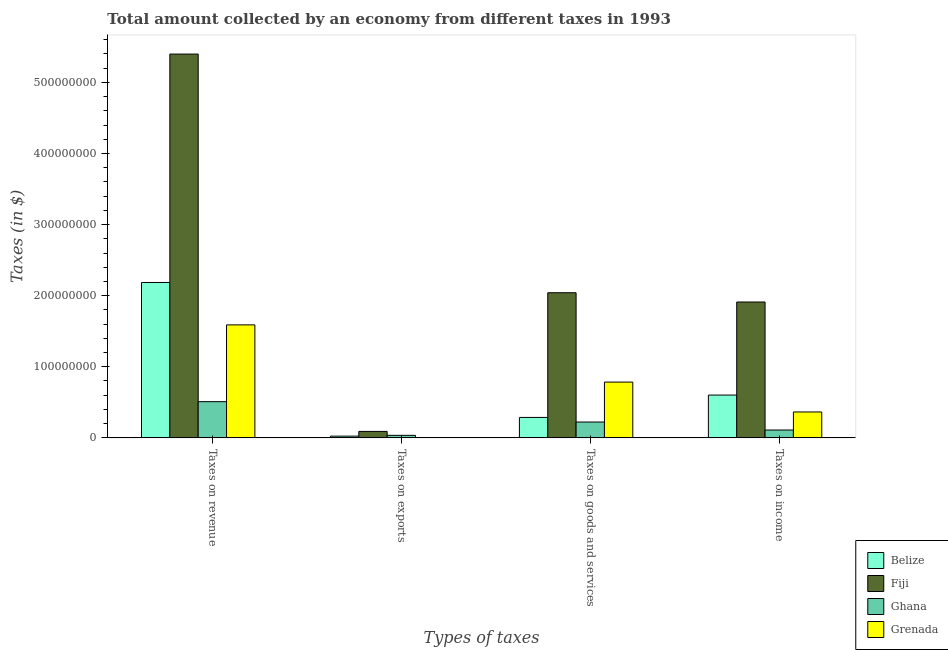Are the number of bars per tick equal to the number of legend labels?
Give a very brief answer. Yes. Are the number of bars on each tick of the X-axis equal?
Ensure brevity in your answer.  Yes. How many bars are there on the 2nd tick from the left?
Offer a very short reply. 4. What is the label of the 3rd group of bars from the left?
Your answer should be compact. Taxes on goods and services. What is the amount collected as tax on income in Grenada?
Offer a terse response. 3.64e+07. Across all countries, what is the maximum amount collected as tax on goods?
Ensure brevity in your answer.  2.04e+08. Across all countries, what is the minimum amount collected as tax on exports?
Provide a short and direct response. 10000. In which country was the amount collected as tax on revenue maximum?
Keep it short and to the point. Fiji. What is the total amount collected as tax on exports in the graph?
Keep it short and to the point. 1.51e+07. What is the difference between the amount collected as tax on income in Fiji and that in Grenada?
Make the answer very short. 1.55e+08. What is the difference between the amount collected as tax on goods in Ghana and the amount collected as tax on exports in Grenada?
Provide a short and direct response. 2.23e+07. What is the average amount collected as tax on exports per country?
Your response must be concise. 3.78e+06. What is the difference between the amount collected as tax on goods and amount collected as tax on revenue in Grenada?
Keep it short and to the point. -8.05e+07. In how many countries, is the amount collected as tax on revenue greater than 280000000 $?
Keep it short and to the point. 1. What is the ratio of the amount collected as tax on income in Belize to that in Fiji?
Ensure brevity in your answer.  0.31. What is the difference between the highest and the second highest amount collected as tax on income?
Offer a very short reply. 1.31e+08. What is the difference between the highest and the lowest amount collected as tax on income?
Your response must be concise. 1.80e+08. In how many countries, is the amount collected as tax on goods greater than the average amount collected as tax on goods taken over all countries?
Your answer should be compact. 1. Is the sum of the amount collected as tax on exports in Ghana and Grenada greater than the maximum amount collected as tax on goods across all countries?
Offer a terse response. No. Is it the case that in every country, the sum of the amount collected as tax on goods and amount collected as tax on income is greater than the sum of amount collected as tax on revenue and amount collected as tax on exports?
Your answer should be very brief. No. What does the 3rd bar from the left in Taxes on goods and services represents?
Make the answer very short. Ghana. What does the 3rd bar from the right in Taxes on income represents?
Your answer should be very brief. Fiji. Are all the bars in the graph horizontal?
Offer a terse response. No. How many countries are there in the graph?
Keep it short and to the point. 4. What is the difference between two consecutive major ticks on the Y-axis?
Your answer should be compact. 1.00e+08. Are the values on the major ticks of Y-axis written in scientific E-notation?
Your answer should be very brief. No. Does the graph contain grids?
Your answer should be very brief. No. Where does the legend appear in the graph?
Give a very brief answer. Bottom right. How are the legend labels stacked?
Make the answer very short. Vertical. What is the title of the graph?
Provide a succinct answer. Total amount collected by an economy from different taxes in 1993. What is the label or title of the X-axis?
Provide a succinct answer. Types of taxes. What is the label or title of the Y-axis?
Offer a terse response. Taxes (in $). What is the Taxes (in $) in Belize in Taxes on revenue?
Provide a succinct answer. 2.19e+08. What is the Taxes (in $) of Fiji in Taxes on revenue?
Keep it short and to the point. 5.40e+08. What is the Taxes (in $) in Ghana in Taxes on revenue?
Provide a succinct answer. 5.09e+07. What is the Taxes (in $) in Grenada in Taxes on revenue?
Offer a very short reply. 1.59e+08. What is the Taxes (in $) in Belize in Taxes on exports?
Your response must be concise. 2.45e+06. What is the Taxes (in $) in Fiji in Taxes on exports?
Your answer should be compact. 9.08e+06. What is the Taxes (in $) of Ghana in Taxes on exports?
Make the answer very short. 3.57e+06. What is the Taxes (in $) of Belize in Taxes on goods and services?
Your answer should be very brief. 2.88e+07. What is the Taxes (in $) in Fiji in Taxes on goods and services?
Provide a short and direct response. 2.04e+08. What is the Taxes (in $) of Ghana in Taxes on goods and services?
Ensure brevity in your answer.  2.23e+07. What is the Taxes (in $) of Grenada in Taxes on goods and services?
Provide a succinct answer. 7.85e+07. What is the Taxes (in $) in Belize in Taxes on income?
Your response must be concise. 6.02e+07. What is the Taxes (in $) of Fiji in Taxes on income?
Give a very brief answer. 1.91e+08. What is the Taxes (in $) of Ghana in Taxes on income?
Your answer should be compact. 1.10e+07. What is the Taxes (in $) in Grenada in Taxes on income?
Ensure brevity in your answer.  3.64e+07. Across all Types of taxes, what is the maximum Taxes (in $) in Belize?
Give a very brief answer. 2.19e+08. Across all Types of taxes, what is the maximum Taxes (in $) of Fiji?
Your answer should be very brief. 5.40e+08. Across all Types of taxes, what is the maximum Taxes (in $) of Ghana?
Your response must be concise. 5.09e+07. Across all Types of taxes, what is the maximum Taxes (in $) in Grenada?
Your answer should be compact. 1.59e+08. Across all Types of taxes, what is the minimum Taxes (in $) in Belize?
Offer a terse response. 2.45e+06. Across all Types of taxes, what is the minimum Taxes (in $) of Fiji?
Ensure brevity in your answer.  9.08e+06. Across all Types of taxes, what is the minimum Taxes (in $) of Ghana?
Provide a succinct answer. 3.57e+06. Across all Types of taxes, what is the minimum Taxes (in $) in Grenada?
Your answer should be very brief. 10000. What is the total Taxes (in $) of Belize in the graph?
Your answer should be very brief. 3.10e+08. What is the total Taxes (in $) in Fiji in the graph?
Provide a succinct answer. 9.44e+08. What is the total Taxes (in $) of Ghana in the graph?
Keep it short and to the point. 8.78e+07. What is the total Taxes (in $) of Grenada in the graph?
Your response must be concise. 2.74e+08. What is the difference between the Taxes (in $) in Belize in Taxes on revenue and that in Taxes on exports?
Provide a succinct answer. 2.16e+08. What is the difference between the Taxes (in $) in Fiji in Taxes on revenue and that in Taxes on exports?
Keep it short and to the point. 5.31e+08. What is the difference between the Taxes (in $) of Ghana in Taxes on revenue and that in Taxes on exports?
Ensure brevity in your answer.  4.73e+07. What is the difference between the Taxes (in $) in Grenada in Taxes on revenue and that in Taxes on exports?
Ensure brevity in your answer.  1.59e+08. What is the difference between the Taxes (in $) of Belize in Taxes on revenue and that in Taxes on goods and services?
Ensure brevity in your answer.  1.90e+08. What is the difference between the Taxes (in $) of Fiji in Taxes on revenue and that in Taxes on goods and services?
Provide a succinct answer. 3.36e+08. What is the difference between the Taxes (in $) in Ghana in Taxes on revenue and that in Taxes on goods and services?
Give a very brief answer. 2.86e+07. What is the difference between the Taxes (in $) of Grenada in Taxes on revenue and that in Taxes on goods and services?
Give a very brief answer. 8.05e+07. What is the difference between the Taxes (in $) in Belize in Taxes on revenue and that in Taxes on income?
Your answer should be very brief. 1.58e+08. What is the difference between the Taxes (in $) in Fiji in Taxes on revenue and that in Taxes on income?
Your response must be concise. 3.49e+08. What is the difference between the Taxes (in $) in Ghana in Taxes on revenue and that in Taxes on income?
Give a very brief answer. 3.99e+07. What is the difference between the Taxes (in $) in Grenada in Taxes on revenue and that in Taxes on income?
Offer a very short reply. 1.22e+08. What is the difference between the Taxes (in $) in Belize in Taxes on exports and that in Taxes on goods and services?
Make the answer very short. -2.63e+07. What is the difference between the Taxes (in $) of Fiji in Taxes on exports and that in Taxes on goods and services?
Provide a short and direct response. -1.95e+08. What is the difference between the Taxes (in $) in Ghana in Taxes on exports and that in Taxes on goods and services?
Make the answer very short. -1.87e+07. What is the difference between the Taxes (in $) in Grenada in Taxes on exports and that in Taxes on goods and services?
Offer a terse response. -7.85e+07. What is the difference between the Taxes (in $) of Belize in Taxes on exports and that in Taxes on income?
Keep it short and to the point. -5.77e+07. What is the difference between the Taxes (in $) in Fiji in Taxes on exports and that in Taxes on income?
Provide a short and direct response. -1.82e+08. What is the difference between the Taxes (in $) of Ghana in Taxes on exports and that in Taxes on income?
Make the answer very short. -7.46e+06. What is the difference between the Taxes (in $) of Grenada in Taxes on exports and that in Taxes on income?
Make the answer very short. -3.64e+07. What is the difference between the Taxes (in $) of Belize in Taxes on goods and services and that in Taxes on income?
Offer a very short reply. -3.14e+07. What is the difference between the Taxes (in $) of Fiji in Taxes on goods and services and that in Taxes on income?
Offer a terse response. 1.30e+07. What is the difference between the Taxes (in $) of Ghana in Taxes on goods and services and that in Taxes on income?
Provide a succinct answer. 1.13e+07. What is the difference between the Taxes (in $) in Grenada in Taxes on goods and services and that in Taxes on income?
Your response must be concise. 4.20e+07. What is the difference between the Taxes (in $) of Belize in Taxes on revenue and the Taxes (in $) of Fiji in Taxes on exports?
Your response must be concise. 2.10e+08. What is the difference between the Taxes (in $) in Belize in Taxes on revenue and the Taxes (in $) in Ghana in Taxes on exports?
Ensure brevity in your answer.  2.15e+08. What is the difference between the Taxes (in $) of Belize in Taxes on revenue and the Taxes (in $) of Grenada in Taxes on exports?
Provide a short and direct response. 2.19e+08. What is the difference between the Taxes (in $) of Fiji in Taxes on revenue and the Taxes (in $) of Ghana in Taxes on exports?
Give a very brief answer. 5.36e+08. What is the difference between the Taxes (in $) in Fiji in Taxes on revenue and the Taxes (in $) in Grenada in Taxes on exports?
Ensure brevity in your answer.  5.40e+08. What is the difference between the Taxes (in $) in Ghana in Taxes on revenue and the Taxes (in $) in Grenada in Taxes on exports?
Ensure brevity in your answer.  5.09e+07. What is the difference between the Taxes (in $) of Belize in Taxes on revenue and the Taxes (in $) of Fiji in Taxes on goods and services?
Your answer should be very brief. 1.45e+07. What is the difference between the Taxes (in $) of Belize in Taxes on revenue and the Taxes (in $) of Ghana in Taxes on goods and services?
Provide a succinct answer. 1.96e+08. What is the difference between the Taxes (in $) of Belize in Taxes on revenue and the Taxes (in $) of Grenada in Taxes on goods and services?
Your response must be concise. 1.40e+08. What is the difference between the Taxes (in $) of Fiji in Taxes on revenue and the Taxes (in $) of Ghana in Taxes on goods and services?
Make the answer very short. 5.18e+08. What is the difference between the Taxes (in $) of Fiji in Taxes on revenue and the Taxes (in $) of Grenada in Taxes on goods and services?
Ensure brevity in your answer.  4.61e+08. What is the difference between the Taxes (in $) in Ghana in Taxes on revenue and the Taxes (in $) in Grenada in Taxes on goods and services?
Your answer should be compact. -2.76e+07. What is the difference between the Taxes (in $) of Belize in Taxes on revenue and the Taxes (in $) of Fiji in Taxes on income?
Your answer should be compact. 2.75e+07. What is the difference between the Taxes (in $) in Belize in Taxes on revenue and the Taxes (in $) in Ghana in Taxes on income?
Give a very brief answer. 2.08e+08. What is the difference between the Taxes (in $) of Belize in Taxes on revenue and the Taxes (in $) of Grenada in Taxes on income?
Keep it short and to the point. 1.82e+08. What is the difference between the Taxes (in $) of Fiji in Taxes on revenue and the Taxes (in $) of Ghana in Taxes on income?
Keep it short and to the point. 5.29e+08. What is the difference between the Taxes (in $) in Fiji in Taxes on revenue and the Taxes (in $) in Grenada in Taxes on income?
Provide a short and direct response. 5.03e+08. What is the difference between the Taxes (in $) of Ghana in Taxes on revenue and the Taxes (in $) of Grenada in Taxes on income?
Your answer should be compact. 1.45e+07. What is the difference between the Taxes (in $) of Belize in Taxes on exports and the Taxes (in $) of Fiji in Taxes on goods and services?
Give a very brief answer. -2.02e+08. What is the difference between the Taxes (in $) in Belize in Taxes on exports and the Taxes (in $) in Ghana in Taxes on goods and services?
Ensure brevity in your answer.  -1.98e+07. What is the difference between the Taxes (in $) of Belize in Taxes on exports and the Taxes (in $) of Grenada in Taxes on goods and services?
Offer a very short reply. -7.60e+07. What is the difference between the Taxes (in $) of Fiji in Taxes on exports and the Taxes (in $) of Ghana in Taxes on goods and services?
Give a very brief answer. -1.32e+07. What is the difference between the Taxes (in $) in Fiji in Taxes on exports and the Taxes (in $) in Grenada in Taxes on goods and services?
Make the answer very short. -6.94e+07. What is the difference between the Taxes (in $) in Ghana in Taxes on exports and the Taxes (in $) in Grenada in Taxes on goods and services?
Keep it short and to the point. -7.49e+07. What is the difference between the Taxes (in $) of Belize in Taxes on exports and the Taxes (in $) of Fiji in Taxes on income?
Your answer should be compact. -1.89e+08. What is the difference between the Taxes (in $) of Belize in Taxes on exports and the Taxes (in $) of Ghana in Taxes on income?
Give a very brief answer. -8.58e+06. What is the difference between the Taxes (in $) in Belize in Taxes on exports and the Taxes (in $) in Grenada in Taxes on income?
Give a very brief answer. -3.40e+07. What is the difference between the Taxes (in $) in Fiji in Taxes on exports and the Taxes (in $) in Ghana in Taxes on income?
Make the answer very short. -1.95e+06. What is the difference between the Taxes (in $) of Fiji in Taxes on exports and the Taxes (in $) of Grenada in Taxes on income?
Your answer should be very brief. -2.74e+07. What is the difference between the Taxes (in $) of Ghana in Taxes on exports and the Taxes (in $) of Grenada in Taxes on income?
Offer a very short reply. -3.29e+07. What is the difference between the Taxes (in $) in Belize in Taxes on goods and services and the Taxes (in $) in Fiji in Taxes on income?
Your answer should be compact. -1.62e+08. What is the difference between the Taxes (in $) in Belize in Taxes on goods and services and the Taxes (in $) in Ghana in Taxes on income?
Your response must be concise. 1.77e+07. What is the difference between the Taxes (in $) of Belize in Taxes on goods and services and the Taxes (in $) of Grenada in Taxes on income?
Your answer should be very brief. -7.69e+06. What is the difference between the Taxes (in $) in Fiji in Taxes on goods and services and the Taxes (in $) in Ghana in Taxes on income?
Ensure brevity in your answer.  1.93e+08. What is the difference between the Taxes (in $) of Fiji in Taxes on goods and services and the Taxes (in $) of Grenada in Taxes on income?
Make the answer very short. 1.68e+08. What is the difference between the Taxes (in $) of Ghana in Taxes on goods and services and the Taxes (in $) of Grenada in Taxes on income?
Provide a short and direct response. -1.42e+07. What is the average Taxes (in $) of Belize per Types of taxes?
Ensure brevity in your answer.  7.75e+07. What is the average Taxes (in $) of Fiji per Types of taxes?
Offer a very short reply. 2.36e+08. What is the average Taxes (in $) in Ghana per Types of taxes?
Keep it short and to the point. 2.20e+07. What is the average Taxes (in $) of Grenada per Types of taxes?
Offer a very short reply. 6.85e+07. What is the difference between the Taxes (in $) in Belize and Taxes (in $) in Fiji in Taxes on revenue?
Offer a very short reply. -3.21e+08. What is the difference between the Taxes (in $) of Belize and Taxes (in $) of Ghana in Taxes on revenue?
Make the answer very short. 1.68e+08. What is the difference between the Taxes (in $) in Belize and Taxes (in $) in Grenada in Taxes on revenue?
Provide a succinct answer. 5.96e+07. What is the difference between the Taxes (in $) in Fiji and Taxes (in $) in Ghana in Taxes on revenue?
Your answer should be compact. 4.89e+08. What is the difference between the Taxes (in $) of Fiji and Taxes (in $) of Grenada in Taxes on revenue?
Your response must be concise. 3.81e+08. What is the difference between the Taxes (in $) in Ghana and Taxes (in $) in Grenada in Taxes on revenue?
Offer a very short reply. -1.08e+08. What is the difference between the Taxes (in $) of Belize and Taxes (in $) of Fiji in Taxes on exports?
Give a very brief answer. -6.63e+06. What is the difference between the Taxes (in $) in Belize and Taxes (in $) in Ghana in Taxes on exports?
Keep it short and to the point. -1.12e+06. What is the difference between the Taxes (in $) of Belize and Taxes (in $) of Grenada in Taxes on exports?
Ensure brevity in your answer.  2.44e+06. What is the difference between the Taxes (in $) of Fiji and Taxes (in $) of Ghana in Taxes on exports?
Offer a terse response. 5.51e+06. What is the difference between the Taxes (in $) of Fiji and Taxes (in $) of Grenada in Taxes on exports?
Offer a very short reply. 9.07e+06. What is the difference between the Taxes (in $) of Ghana and Taxes (in $) of Grenada in Taxes on exports?
Your answer should be compact. 3.56e+06. What is the difference between the Taxes (in $) in Belize and Taxes (in $) in Fiji in Taxes on goods and services?
Provide a succinct answer. -1.75e+08. What is the difference between the Taxes (in $) of Belize and Taxes (in $) of Ghana in Taxes on goods and services?
Your answer should be very brief. 6.46e+06. What is the difference between the Taxes (in $) in Belize and Taxes (in $) in Grenada in Taxes on goods and services?
Give a very brief answer. -4.97e+07. What is the difference between the Taxes (in $) of Fiji and Taxes (in $) of Ghana in Taxes on goods and services?
Offer a terse response. 1.82e+08. What is the difference between the Taxes (in $) in Fiji and Taxes (in $) in Grenada in Taxes on goods and services?
Your response must be concise. 1.26e+08. What is the difference between the Taxes (in $) in Ghana and Taxes (in $) in Grenada in Taxes on goods and services?
Your answer should be compact. -5.62e+07. What is the difference between the Taxes (in $) of Belize and Taxes (in $) of Fiji in Taxes on income?
Provide a succinct answer. -1.31e+08. What is the difference between the Taxes (in $) of Belize and Taxes (in $) of Ghana in Taxes on income?
Offer a very short reply. 4.92e+07. What is the difference between the Taxes (in $) of Belize and Taxes (in $) of Grenada in Taxes on income?
Keep it short and to the point. 2.38e+07. What is the difference between the Taxes (in $) of Fiji and Taxes (in $) of Ghana in Taxes on income?
Your answer should be very brief. 1.80e+08. What is the difference between the Taxes (in $) of Fiji and Taxes (in $) of Grenada in Taxes on income?
Your response must be concise. 1.55e+08. What is the difference between the Taxes (in $) of Ghana and Taxes (in $) of Grenada in Taxes on income?
Keep it short and to the point. -2.54e+07. What is the ratio of the Taxes (in $) in Belize in Taxes on revenue to that in Taxes on exports?
Your answer should be compact. 89.11. What is the ratio of the Taxes (in $) in Fiji in Taxes on revenue to that in Taxes on exports?
Your answer should be compact. 59.46. What is the ratio of the Taxes (in $) of Ghana in Taxes on revenue to that in Taxes on exports?
Provide a short and direct response. 14.24. What is the ratio of the Taxes (in $) of Grenada in Taxes on revenue to that in Taxes on exports?
Offer a terse response. 1.59e+04. What is the ratio of the Taxes (in $) in Belize in Taxes on revenue to that in Taxes on goods and services?
Make the answer very short. 7.6. What is the ratio of the Taxes (in $) of Fiji in Taxes on revenue to that in Taxes on goods and services?
Your response must be concise. 2.64. What is the ratio of the Taxes (in $) in Ghana in Taxes on revenue to that in Taxes on goods and services?
Your response must be concise. 2.28. What is the ratio of the Taxes (in $) in Grenada in Taxes on revenue to that in Taxes on goods and services?
Ensure brevity in your answer.  2.03. What is the ratio of the Taxes (in $) in Belize in Taxes on revenue to that in Taxes on income?
Provide a succinct answer. 3.63. What is the ratio of the Taxes (in $) of Fiji in Taxes on revenue to that in Taxes on income?
Your response must be concise. 2.82. What is the ratio of the Taxes (in $) in Ghana in Taxes on revenue to that in Taxes on income?
Your response must be concise. 4.62. What is the ratio of the Taxes (in $) of Grenada in Taxes on revenue to that in Taxes on income?
Your answer should be compact. 4.36. What is the ratio of the Taxes (in $) of Belize in Taxes on exports to that in Taxes on goods and services?
Offer a terse response. 0.09. What is the ratio of the Taxes (in $) in Fiji in Taxes on exports to that in Taxes on goods and services?
Keep it short and to the point. 0.04. What is the ratio of the Taxes (in $) in Ghana in Taxes on exports to that in Taxes on goods and services?
Ensure brevity in your answer.  0.16. What is the ratio of the Taxes (in $) of Grenada in Taxes on exports to that in Taxes on goods and services?
Offer a terse response. 0. What is the ratio of the Taxes (in $) in Belize in Taxes on exports to that in Taxes on income?
Offer a very short reply. 0.04. What is the ratio of the Taxes (in $) in Fiji in Taxes on exports to that in Taxes on income?
Give a very brief answer. 0.05. What is the ratio of the Taxes (in $) in Ghana in Taxes on exports to that in Taxes on income?
Your answer should be compact. 0.32. What is the ratio of the Taxes (in $) of Belize in Taxes on goods and services to that in Taxes on income?
Offer a terse response. 0.48. What is the ratio of the Taxes (in $) in Fiji in Taxes on goods and services to that in Taxes on income?
Provide a succinct answer. 1.07. What is the ratio of the Taxes (in $) of Ghana in Taxes on goods and services to that in Taxes on income?
Your response must be concise. 2.02. What is the ratio of the Taxes (in $) in Grenada in Taxes on goods and services to that in Taxes on income?
Offer a terse response. 2.15. What is the difference between the highest and the second highest Taxes (in $) of Belize?
Your answer should be compact. 1.58e+08. What is the difference between the highest and the second highest Taxes (in $) of Fiji?
Ensure brevity in your answer.  3.36e+08. What is the difference between the highest and the second highest Taxes (in $) in Ghana?
Provide a short and direct response. 2.86e+07. What is the difference between the highest and the second highest Taxes (in $) of Grenada?
Ensure brevity in your answer.  8.05e+07. What is the difference between the highest and the lowest Taxes (in $) in Belize?
Offer a terse response. 2.16e+08. What is the difference between the highest and the lowest Taxes (in $) in Fiji?
Give a very brief answer. 5.31e+08. What is the difference between the highest and the lowest Taxes (in $) of Ghana?
Offer a very short reply. 4.73e+07. What is the difference between the highest and the lowest Taxes (in $) of Grenada?
Provide a succinct answer. 1.59e+08. 